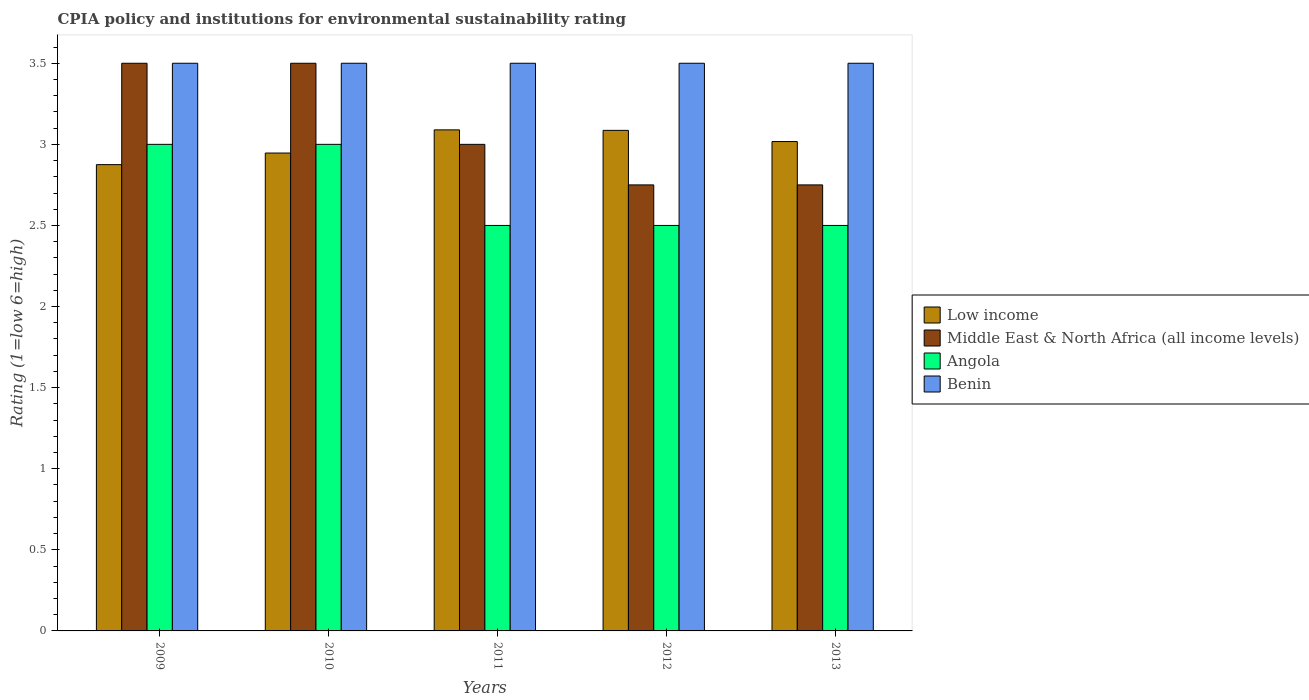How many different coloured bars are there?
Give a very brief answer. 4. Are the number of bars on each tick of the X-axis equal?
Keep it short and to the point. Yes. How many bars are there on the 3rd tick from the left?
Give a very brief answer. 4. How many bars are there on the 4th tick from the right?
Keep it short and to the point. 4. In how many cases, is the number of bars for a given year not equal to the number of legend labels?
Your answer should be compact. 0. What is the CPIA rating in Low income in 2009?
Your response must be concise. 2.88. Across all years, what is the maximum CPIA rating in Angola?
Offer a very short reply. 3. Across all years, what is the minimum CPIA rating in Low income?
Provide a short and direct response. 2.88. In which year was the CPIA rating in Angola maximum?
Your answer should be compact. 2009. What is the total CPIA rating in Low income in the graph?
Your response must be concise. 15.01. What is the difference between the CPIA rating in Low income in 2010 and that in 2012?
Your response must be concise. -0.14. What is the difference between the CPIA rating in Angola in 2009 and the CPIA rating in Benin in 2013?
Offer a terse response. -0.5. In how many years, is the CPIA rating in Middle East & North Africa (all income levels) greater than 3.1?
Provide a short and direct response. 2. What is the ratio of the CPIA rating in Benin in 2009 to that in 2013?
Provide a succinct answer. 1. Is the difference between the CPIA rating in Benin in 2010 and 2012 greater than the difference between the CPIA rating in Angola in 2010 and 2012?
Offer a very short reply. No. What is the difference between the highest and the lowest CPIA rating in Low income?
Offer a very short reply. 0.21. In how many years, is the CPIA rating in Benin greater than the average CPIA rating in Benin taken over all years?
Keep it short and to the point. 0. Is it the case that in every year, the sum of the CPIA rating in Angola and CPIA rating in Middle East & North Africa (all income levels) is greater than the sum of CPIA rating in Low income and CPIA rating in Benin?
Make the answer very short. No. What does the 3rd bar from the right in 2013 represents?
Ensure brevity in your answer.  Middle East & North Africa (all income levels). How many bars are there?
Provide a succinct answer. 20. Are all the bars in the graph horizontal?
Provide a short and direct response. No. What is the difference between two consecutive major ticks on the Y-axis?
Ensure brevity in your answer.  0.5. Are the values on the major ticks of Y-axis written in scientific E-notation?
Your answer should be compact. No. Does the graph contain any zero values?
Your answer should be very brief. No. Does the graph contain grids?
Offer a very short reply. No. Where does the legend appear in the graph?
Your answer should be compact. Center right. How are the legend labels stacked?
Give a very brief answer. Vertical. What is the title of the graph?
Offer a very short reply. CPIA policy and institutions for environmental sustainability rating. Does "Argentina" appear as one of the legend labels in the graph?
Keep it short and to the point. No. What is the label or title of the X-axis?
Your answer should be compact. Years. What is the Rating (1=low 6=high) of Low income in 2009?
Ensure brevity in your answer.  2.88. What is the Rating (1=low 6=high) of Middle East & North Africa (all income levels) in 2009?
Give a very brief answer. 3.5. What is the Rating (1=low 6=high) in Low income in 2010?
Keep it short and to the point. 2.95. What is the Rating (1=low 6=high) of Angola in 2010?
Provide a succinct answer. 3. What is the Rating (1=low 6=high) in Benin in 2010?
Your response must be concise. 3.5. What is the Rating (1=low 6=high) in Low income in 2011?
Provide a succinct answer. 3.09. What is the Rating (1=low 6=high) in Angola in 2011?
Keep it short and to the point. 2.5. What is the Rating (1=low 6=high) in Benin in 2011?
Offer a terse response. 3.5. What is the Rating (1=low 6=high) in Low income in 2012?
Provide a succinct answer. 3.09. What is the Rating (1=low 6=high) in Middle East & North Africa (all income levels) in 2012?
Your answer should be very brief. 2.75. What is the Rating (1=low 6=high) in Benin in 2012?
Your response must be concise. 3.5. What is the Rating (1=low 6=high) of Low income in 2013?
Your answer should be compact. 3.02. What is the Rating (1=low 6=high) in Middle East & North Africa (all income levels) in 2013?
Your answer should be very brief. 2.75. What is the Rating (1=low 6=high) in Angola in 2013?
Ensure brevity in your answer.  2.5. What is the Rating (1=low 6=high) of Benin in 2013?
Your answer should be very brief. 3.5. Across all years, what is the maximum Rating (1=low 6=high) of Low income?
Give a very brief answer. 3.09. Across all years, what is the maximum Rating (1=low 6=high) in Middle East & North Africa (all income levels)?
Make the answer very short. 3.5. Across all years, what is the maximum Rating (1=low 6=high) of Angola?
Provide a short and direct response. 3. Across all years, what is the maximum Rating (1=low 6=high) of Benin?
Offer a very short reply. 3.5. Across all years, what is the minimum Rating (1=low 6=high) in Low income?
Make the answer very short. 2.88. Across all years, what is the minimum Rating (1=low 6=high) of Middle East & North Africa (all income levels)?
Your answer should be compact. 2.75. What is the total Rating (1=low 6=high) of Low income in the graph?
Ensure brevity in your answer.  15.01. What is the total Rating (1=low 6=high) of Middle East & North Africa (all income levels) in the graph?
Your answer should be compact. 15.5. What is the total Rating (1=low 6=high) in Angola in the graph?
Make the answer very short. 13.5. What is the total Rating (1=low 6=high) in Benin in the graph?
Offer a very short reply. 17.5. What is the difference between the Rating (1=low 6=high) in Low income in 2009 and that in 2010?
Provide a short and direct response. -0.07. What is the difference between the Rating (1=low 6=high) in Middle East & North Africa (all income levels) in 2009 and that in 2010?
Ensure brevity in your answer.  0. What is the difference between the Rating (1=low 6=high) of Angola in 2009 and that in 2010?
Keep it short and to the point. 0. What is the difference between the Rating (1=low 6=high) in Benin in 2009 and that in 2010?
Make the answer very short. 0. What is the difference between the Rating (1=low 6=high) in Low income in 2009 and that in 2011?
Provide a succinct answer. -0.21. What is the difference between the Rating (1=low 6=high) of Middle East & North Africa (all income levels) in 2009 and that in 2011?
Give a very brief answer. 0.5. What is the difference between the Rating (1=low 6=high) in Low income in 2009 and that in 2012?
Offer a terse response. -0.21. What is the difference between the Rating (1=low 6=high) in Middle East & North Africa (all income levels) in 2009 and that in 2012?
Your answer should be compact. 0.75. What is the difference between the Rating (1=low 6=high) in Low income in 2009 and that in 2013?
Provide a succinct answer. -0.14. What is the difference between the Rating (1=low 6=high) in Angola in 2009 and that in 2013?
Provide a short and direct response. 0.5. What is the difference between the Rating (1=low 6=high) in Benin in 2009 and that in 2013?
Give a very brief answer. 0. What is the difference between the Rating (1=low 6=high) of Low income in 2010 and that in 2011?
Offer a very short reply. -0.14. What is the difference between the Rating (1=low 6=high) in Middle East & North Africa (all income levels) in 2010 and that in 2011?
Your answer should be very brief. 0.5. What is the difference between the Rating (1=low 6=high) in Angola in 2010 and that in 2011?
Give a very brief answer. 0.5. What is the difference between the Rating (1=low 6=high) of Benin in 2010 and that in 2011?
Provide a succinct answer. 0. What is the difference between the Rating (1=low 6=high) of Low income in 2010 and that in 2012?
Your answer should be compact. -0.14. What is the difference between the Rating (1=low 6=high) of Middle East & North Africa (all income levels) in 2010 and that in 2012?
Ensure brevity in your answer.  0.75. What is the difference between the Rating (1=low 6=high) in Benin in 2010 and that in 2012?
Ensure brevity in your answer.  0. What is the difference between the Rating (1=low 6=high) of Low income in 2010 and that in 2013?
Keep it short and to the point. -0.07. What is the difference between the Rating (1=low 6=high) in Middle East & North Africa (all income levels) in 2010 and that in 2013?
Give a very brief answer. 0.75. What is the difference between the Rating (1=low 6=high) in Angola in 2010 and that in 2013?
Make the answer very short. 0.5. What is the difference between the Rating (1=low 6=high) in Low income in 2011 and that in 2012?
Keep it short and to the point. 0. What is the difference between the Rating (1=low 6=high) in Benin in 2011 and that in 2012?
Your answer should be compact. 0. What is the difference between the Rating (1=low 6=high) in Low income in 2011 and that in 2013?
Make the answer very short. 0.07. What is the difference between the Rating (1=low 6=high) in Low income in 2012 and that in 2013?
Provide a succinct answer. 0.07. What is the difference between the Rating (1=low 6=high) in Angola in 2012 and that in 2013?
Make the answer very short. 0. What is the difference between the Rating (1=low 6=high) of Benin in 2012 and that in 2013?
Ensure brevity in your answer.  0. What is the difference between the Rating (1=low 6=high) in Low income in 2009 and the Rating (1=low 6=high) in Middle East & North Africa (all income levels) in 2010?
Give a very brief answer. -0.62. What is the difference between the Rating (1=low 6=high) of Low income in 2009 and the Rating (1=low 6=high) of Angola in 2010?
Offer a very short reply. -0.12. What is the difference between the Rating (1=low 6=high) in Low income in 2009 and the Rating (1=low 6=high) in Benin in 2010?
Provide a succinct answer. -0.62. What is the difference between the Rating (1=low 6=high) of Middle East & North Africa (all income levels) in 2009 and the Rating (1=low 6=high) of Benin in 2010?
Make the answer very short. 0. What is the difference between the Rating (1=low 6=high) in Low income in 2009 and the Rating (1=low 6=high) in Middle East & North Africa (all income levels) in 2011?
Your answer should be compact. -0.12. What is the difference between the Rating (1=low 6=high) in Low income in 2009 and the Rating (1=low 6=high) in Benin in 2011?
Provide a succinct answer. -0.62. What is the difference between the Rating (1=low 6=high) of Middle East & North Africa (all income levels) in 2009 and the Rating (1=low 6=high) of Angola in 2011?
Ensure brevity in your answer.  1. What is the difference between the Rating (1=low 6=high) of Angola in 2009 and the Rating (1=low 6=high) of Benin in 2011?
Keep it short and to the point. -0.5. What is the difference between the Rating (1=low 6=high) in Low income in 2009 and the Rating (1=low 6=high) in Middle East & North Africa (all income levels) in 2012?
Your answer should be very brief. 0.12. What is the difference between the Rating (1=low 6=high) of Low income in 2009 and the Rating (1=low 6=high) of Angola in 2012?
Your answer should be very brief. 0.38. What is the difference between the Rating (1=low 6=high) of Low income in 2009 and the Rating (1=low 6=high) of Benin in 2012?
Keep it short and to the point. -0.62. What is the difference between the Rating (1=low 6=high) in Low income in 2009 and the Rating (1=low 6=high) in Middle East & North Africa (all income levels) in 2013?
Your answer should be compact. 0.12. What is the difference between the Rating (1=low 6=high) of Low income in 2009 and the Rating (1=low 6=high) of Benin in 2013?
Give a very brief answer. -0.62. What is the difference between the Rating (1=low 6=high) in Low income in 2010 and the Rating (1=low 6=high) in Middle East & North Africa (all income levels) in 2011?
Provide a short and direct response. -0.05. What is the difference between the Rating (1=low 6=high) of Low income in 2010 and the Rating (1=low 6=high) of Angola in 2011?
Provide a succinct answer. 0.45. What is the difference between the Rating (1=low 6=high) in Low income in 2010 and the Rating (1=low 6=high) in Benin in 2011?
Provide a short and direct response. -0.55. What is the difference between the Rating (1=low 6=high) of Middle East & North Africa (all income levels) in 2010 and the Rating (1=low 6=high) of Benin in 2011?
Give a very brief answer. 0. What is the difference between the Rating (1=low 6=high) in Angola in 2010 and the Rating (1=low 6=high) in Benin in 2011?
Offer a terse response. -0.5. What is the difference between the Rating (1=low 6=high) of Low income in 2010 and the Rating (1=low 6=high) of Middle East & North Africa (all income levels) in 2012?
Keep it short and to the point. 0.2. What is the difference between the Rating (1=low 6=high) of Low income in 2010 and the Rating (1=low 6=high) of Angola in 2012?
Make the answer very short. 0.45. What is the difference between the Rating (1=low 6=high) in Low income in 2010 and the Rating (1=low 6=high) in Benin in 2012?
Your answer should be compact. -0.55. What is the difference between the Rating (1=low 6=high) in Middle East & North Africa (all income levels) in 2010 and the Rating (1=low 6=high) in Benin in 2012?
Provide a short and direct response. 0. What is the difference between the Rating (1=low 6=high) in Low income in 2010 and the Rating (1=low 6=high) in Middle East & North Africa (all income levels) in 2013?
Keep it short and to the point. 0.2. What is the difference between the Rating (1=low 6=high) of Low income in 2010 and the Rating (1=low 6=high) of Angola in 2013?
Make the answer very short. 0.45. What is the difference between the Rating (1=low 6=high) in Low income in 2010 and the Rating (1=low 6=high) in Benin in 2013?
Your answer should be compact. -0.55. What is the difference between the Rating (1=low 6=high) in Middle East & North Africa (all income levels) in 2010 and the Rating (1=low 6=high) in Angola in 2013?
Your response must be concise. 1. What is the difference between the Rating (1=low 6=high) in Low income in 2011 and the Rating (1=low 6=high) in Middle East & North Africa (all income levels) in 2012?
Your answer should be very brief. 0.34. What is the difference between the Rating (1=low 6=high) of Low income in 2011 and the Rating (1=low 6=high) of Angola in 2012?
Provide a short and direct response. 0.59. What is the difference between the Rating (1=low 6=high) in Low income in 2011 and the Rating (1=low 6=high) in Benin in 2012?
Offer a very short reply. -0.41. What is the difference between the Rating (1=low 6=high) in Middle East & North Africa (all income levels) in 2011 and the Rating (1=low 6=high) in Angola in 2012?
Your answer should be very brief. 0.5. What is the difference between the Rating (1=low 6=high) in Middle East & North Africa (all income levels) in 2011 and the Rating (1=low 6=high) in Benin in 2012?
Provide a succinct answer. -0.5. What is the difference between the Rating (1=low 6=high) of Angola in 2011 and the Rating (1=low 6=high) of Benin in 2012?
Your response must be concise. -1. What is the difference between the Rating (1=low 6=high) of Low income in 2011 and the Rating (1=low 6=high) of Middle East & North Africa (all income levels) in 2013?
Give a very brief answer. 0.34. What is the difference between the Rating (1=low 6=high) of Low income in 2011 and the Rating (1=low 6=high) of Angola in 2013?
Ensure brevity in your answer.  0.59. What is the difference between the Rating (1=low 6=high) of Low income in 2011 and the Rating (1=low 6=high) of Benin in 2013?
Give a very brief answer. -0.41. What is the difference between the Rating (1=low 6=high) in Middle East & North Africa (all income levels) in 2011 and the Rating (1=low 6=high) in Benin in 2013?
Your answer should be very brief. -0.5. What is the difference between the Rating (1=low 6=high) of Low income in 2012 and the Rating (1=low 6=high) of Middle East & North Africa (all income levels) in 2013?
Provide a succinct answer. 0.34. What is the difference between the Rating (1=low 6=high) of Low income in 2012 and the Rating (1=low 6=high) of Angola in 2013?
Offer a terse response. 0.59. What is the difference between the Rating (1=low 6=high) in Low income in 2012 and the Rating (1=low 6=high) in Benin in 2013?
Your answer should be very brief. -0.41. What is the difference between the Rating (1=low 6=high) in Middle East & North Africa (all income levels) in 2012 and the Rating (1=low 6=high) in Benin in 2013?
Provide a short and direct response. -0.75. What is the difference between the Rating (1=low 6=high) in Angola in 2012 and the Rating (1=low 6=high) in Benin in 2013?
Make the answer very short. -1. What is the average Rating (1=low 6=high) in Low income per year?
Your response must be concise. 3. What is the average Rating (1=low 6=high) in Benin per year?
Offer a very short reply. 3.5. In the year 2009, what is the difference between the Rating (1=low 6=high) of Low income and Rating (1=low 6=high) of Middle East & North Africa (all income levels)?
Keep it short and to the point. -0.62. In the year 2009, what is the difference between the Rating (1=low 6=high) in Low income and Rating (1=low 6=high) in Angola?
Your answer should be very brief. -0.12. In the year 2009, what is the difference between the Rating (1=low 6=high) in Low income and Rating (1=low 6=high) in Benin?
Your answer should be very brief. -0.62. In the year 2009, what is the difference between the Rating (1=low 6=high) of Middle East & North Africa (all income levels) and Rating (1=low 6=high) of Benin?
Your answer should be very brief. 0. In the year 2010, what is the difference between the Rating (1=low 6=high) in Low income and Rating (1=low 6=high) in Middle East & North Africa (all income levels)?
Offer a terse response. -0.55. In the year 2010, what is the difference between the Rating (1=low 6=high) in Low income and Rating (1=low 6=high) in Angola?
Provide a succinct answer. -0.05. In the year 2010, what is the difference between the Rating (1=low 6=high) in Low income and Rating (1=low 6=high) in Benin?
Offer a very short reply. -0.55. In the year 2010, what is the difference between the Rating (1=low 6=high) of Angola and Rating (1=low 6=high) of Benin?
Your response must be concise. -0.5. In the year 2011, what is the difference between the Rating (1=low 6=high) in Low income and Rating (1=low 6=high) in Middle East & North Africa (all income levels)?
Your answer should be compact. 0.09. In the year 2011, what is the difference between the Rating (1=low 6=high) in Low income and Rating (1=low 6=high) in Angola?
Ensure brevity in your answer.  0.59. In the year 2011, what is the difference between the Rating (1=low 6=high) in Low income and Rating (1=low 6=high) in Benin?
Your answer should be very brief. -0.41. In the year 2011, what is the difference between the Rating (1=low 6=high) of Middle East & North Africa (all income levels) and Rating (1=low 6=high) of Benin?
Provide a succinct answer. -0.5. In the year 2011, what is the difference between the Rating (1=low 6=high) in Angola and Rating (1=low 6=high) in Benin?
Keep it short and to the point. -1. In the year 2012, what is the difference between the Rating (1=low 6=high) in Low income and Rating (1=low 6=high) in Middle East & North Africa (all income levels)?
Provide a short and direct response. 0.34. In the year 2012, what is the difference between the Rating (1=low 6=high) of Low income and Rating (1=low 6=high) of Angola?
Provide a succinct answer. 0.59. In the year 2012, what is the difference between the Rating (1=low 6=high) in Low income and Rating (1=low 6=high) in Benin?
Your response must be concise. -0.41. In the year 2012, what is the difference between the Rating (1=low 6=high) in Middle East & North Africa (all income levels) and Rating (1=low 6=high) in Angola?
Offer a terse response. 0.25. In the year 2012, what is the difference between the Rating (1=low 6=high) of Middle East & North Africa (all income levels) and Rating (1=low 6=high) of Benin?
Provide a short and direct response. -0.75. In the year 2013, what is the difference between the Rating (1=low 6=high) of Low income and Rating (1=low 6=high) of Middle East & North Africa (all income levels)?
Offer a terse response. 0.27. In the year 2013, what is the difference between the Rating (1=low 6=high) of Low income and Rating (1=low 6=high) of Angola?
Give a very brief answer. 0.52. In the year 2013, what is the difference between the Rating (1=low 6=high) in Low income and Rating (1=low 6=high) in Benin?
Ensure brevity in your answer.  -0.48. In the year 2013, what is the difference between the Rating (1=low 6=high) in Middle East & North Africa (all income levels) and Rating (1=low 6=high) in Benin?
Offer a terse response. -0.75. What is the ratio of the Rating (1=low 6=high) of Low income in 2009 to that in 2010?
Make the answer very short. 0.98. What is the ratio of the Rating (1=low 6=high) of Middle East & North Africa (all income levels) in 2009 to that in 2010?
Your answer should be compact. 1. What is the ratio of the Rating (1=low 6=high) in Low income in 2009 to that in 2011?
Provide a short and direct response. 0.93. What is the ratio of the Rating (1=low 6=high) of Middle East & North Africa (all income levels) in 2009 to that in 2011?
Give a very brief answer. 1.17. What is the ratio of the Rating (1=low 6=high) of Low income in 2009 to that in 2012?
Your answer should be compact. 0.93. What is the ratio of the Rating (1=low 6=high) in Middle East & North Africa (all income levels) in 2009 to that in 2012?
Give a very brief answer. 1.27. What is the ratio of the Rating (1=low 6=high) in Angola in 2009 to that in 2012?
Ensure brevity in your answer.  1.2. What is the ratio of the Rating (1=low 6=high) in Low income in 2009 to that in 2013?
Keep it short and to the point. 0.95. What is the ratio of the Rating (1=low 6=high) of Middle East & North Africa (all income levels) in 2009 to that in 2013?
Ensure brevity in your answer.  1.27. What is the ratio of the Rating (1=low 6=high) of Low income in 2010 to that in 2011?
Offer a very short reply. 0.95. What is the ratio of the Rating (1=low 6=high) in Middle East & North Africa (all income levels) in 2010 to that in 2011?
Provide a succinct answer. 1.17. What is the ratio of the Rating (1=low 6=high) in Benin in 2010 to that in 2011?
Ensure brevity in your answer.  1. What is the ratio of the Rating (1=low 6=high) of Low income in 2010 to that in 2012?
Make the answer very short. 0.95. What is the ratio of the Rating (1=low 6=high) of Middle East & North Africa (all income levels) in 2010 to that in 2012?
Make the answer very short. 1.27. What is the ratio of the Rating (1=low 6=high) of Benin in 2010 to that in 2012?
Make the answer very short. 1. What is the ratio of the Rating (1=low 6=high) in Low income in 2010 to that in 2013?
Your answer should be compact. 0.98. What is the ratio of the Rating (1=low 6=high) in Middle East & North Africa (all income levels) in 2010 to that in 2013?
Keep it short and to the point. 1.27. What is the ratio of the Rating (1=low 6=high) in Angola in 2010 to that in 2013?
Offer a terse response. 1.2. What is the ratio of the Rating (1=low 6=high) in Benin in 2010 to that in 2013?
Keep it short and to the point. 1. What is the ratio of the Rating (1=low 6=high) of Low income in 2011 to that in 2012?
Your answer should be compact. 1. What is the ratio of the Rating (1=low 6=high) in Middle East & North Africa (all income levels) in 2011 to that in 2012?
Make the answer very short. 1.09. What is the ratio of the Rating (1=low 6=high) in Angola in 2011 to that in 2012?
Keep it short and to the point. 1. What is the ratio of the Rating (1=low 6=high) of Low income in 2011 to that in 2013?
Ensure brevity in your answer.  1.02. What is the ratio of the Rating (1=low 6=high) in Angola in 2011 to that in 2013?
Make the answer very short. 1. What is the ratio of the Rating (1=low 6=high) of Benin in 2011 to that in 2013?
Keep it short and to the point. 1. What is the ratio of the Rating (1=low 6=high) in Low income in 2012 to that in 2013?
Your response must be concise. 1.02. What is the ratio of the Rating (1=low 6=high) in Middle East & North Africa (all income levels) in 2012 to that in 2013?
Your answer should be very brief. 1. What is the ratio of the Rating (1=low 6=high) of Angola in 2012 to that in 2013?
Your answer should be very brief. 1. What is the difference between the highest and the second highest Rating (1=low 6=high) of Low income?
Your answer should be very brief. 0. What is the difference between the highest and the second highest Rating (1=low 6=high) of Benin?
Your answer should be very brief. 0. What is the difference between the highest and the lowest Rating (1=low 6=high) in Low income?
Keep it short and to the point. 0.21. What is the difference between the highest and the lowest Rating (1=low 6=high) of Angola?
Your response must be concise. 0.5. What is the difference between the highest and the lowest Rating (1=low 6=high) in Benin?
Provide a short and direct response. 0. 